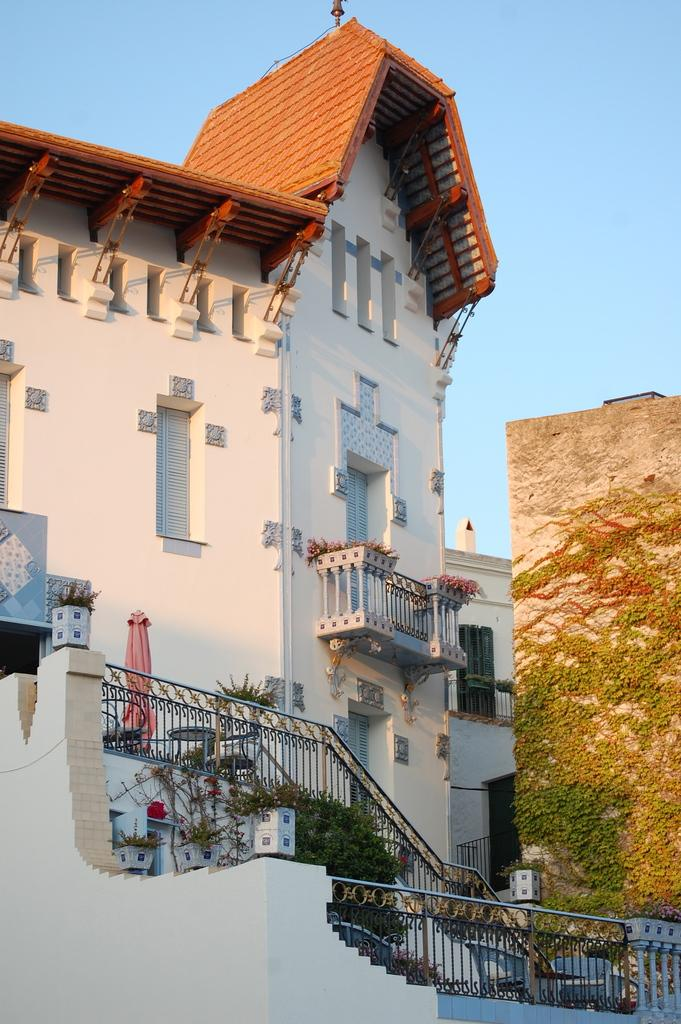What type of structures can be seen in the image? There are buildings in the image. What other elements are present in the image besides buildings? There are plants and a railing visible in the image. What is on the right side of the image? There is a wall on the right side of the image. What is visible at the top of the image? The sky is visible at the top of the image. How many lizards can be seen crawling on the wall in the image? There are no lizards present in the image; it only features buildings, plants, a railing, and a wall. What type of ear is visible on the building in the image? There is no ear present in the image, as ears are a part of the human body and not a feature of buildings. 